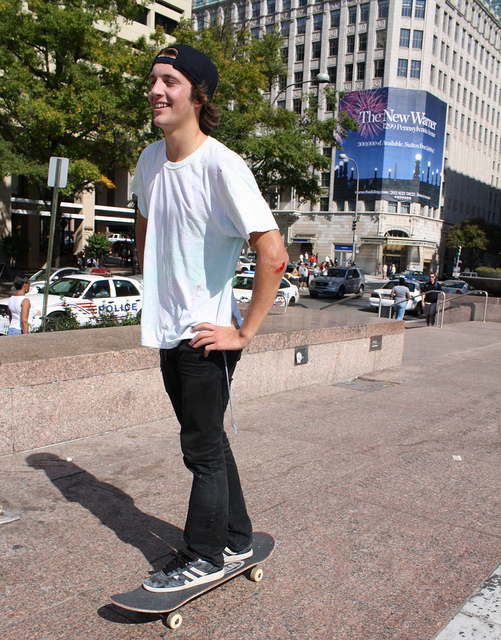Identify the text contained in this image. The New POLICE 